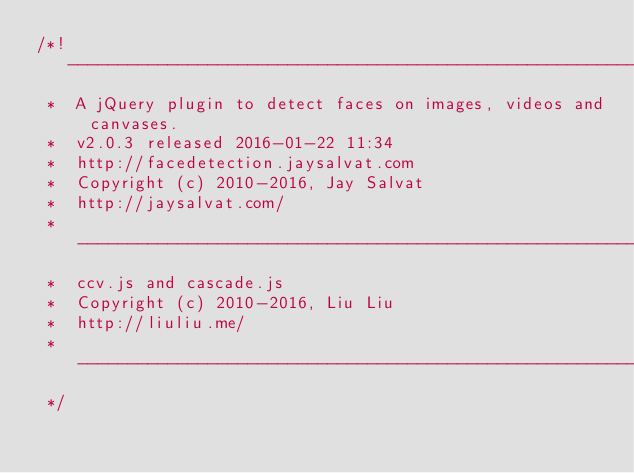Convert code to text. <code><loc_0><loc_0><loc_500><loc_500><_JavaScript_>/*! ----------------------------------------------------------------------------
 *  A jQuery plugin to detect faces on images, videos and canvases.
 *  v2.0.3 released 2016-01-22 11:34
 *  http://facedetection.jaysalvat.com
 *  Copyright (c) 2010-2016, Jay Salvat
 *  http://jaysalvat.com/
 *  ----------------------------------------------------------------------------
 *  ccv.js and cascade.js
 *  Copyright (c) 2010-2016, Liu Liu
 *  http://liuliu.me/
 *  ----------------------------------------------------------------------------
 */</code> 